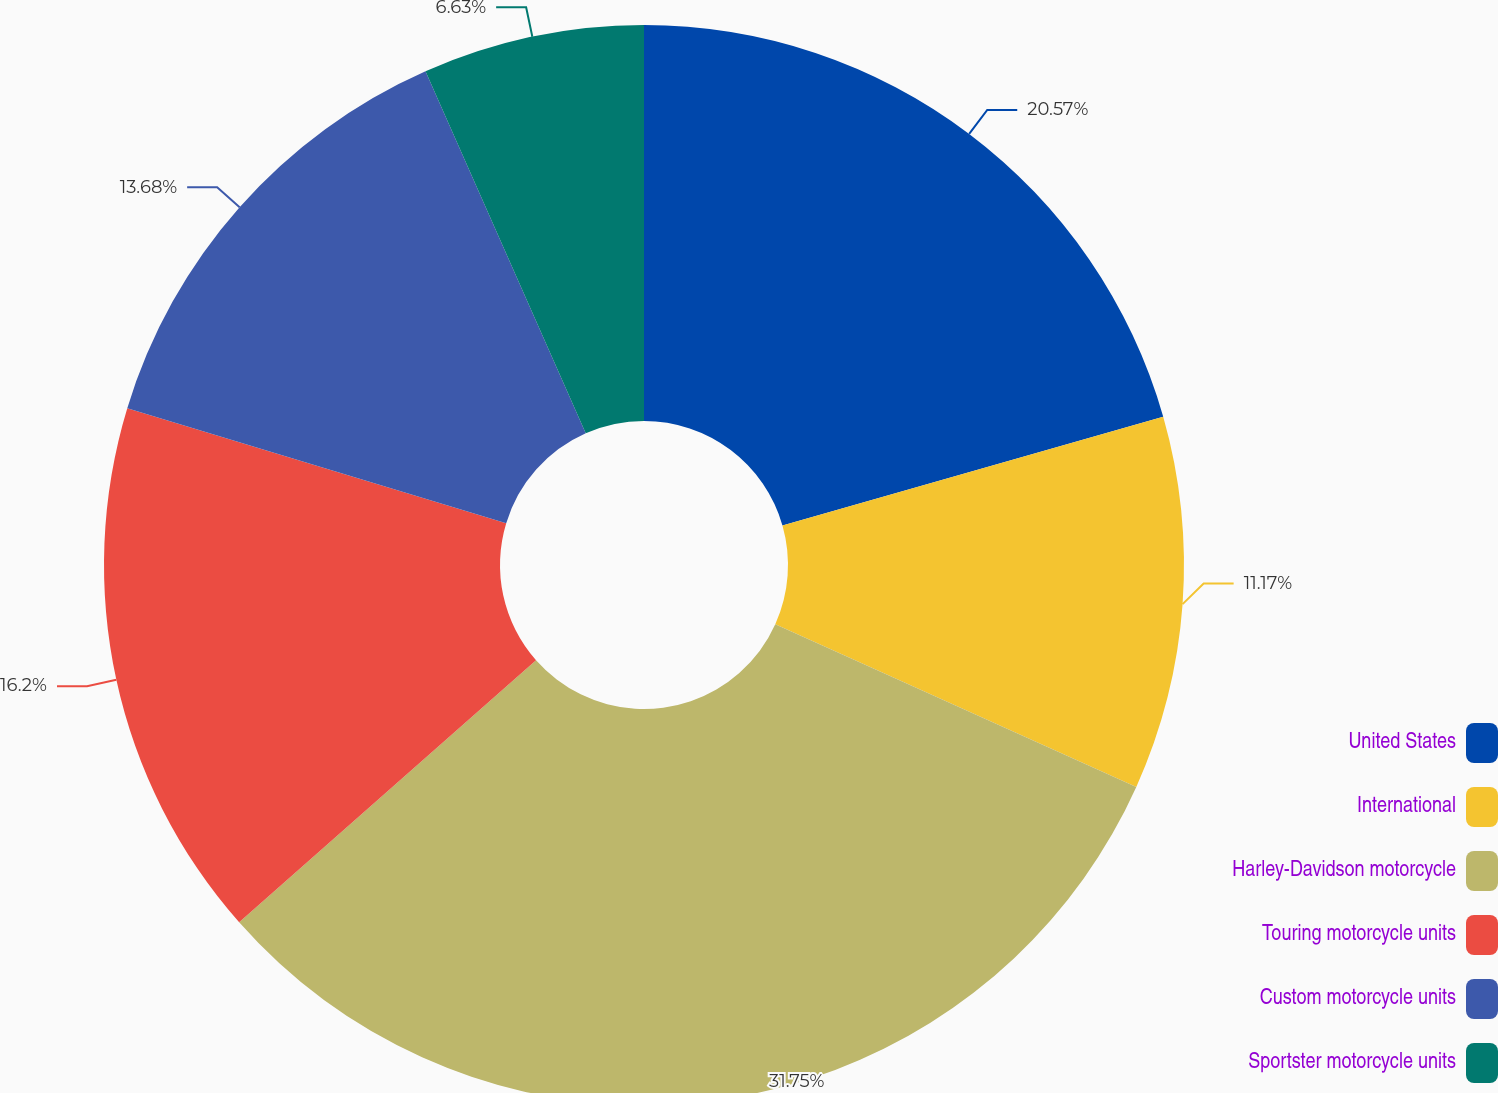<chart> <loc_0><loc_0><loc_500><loc_500><pie_chart><fcel>United States<fcel>International<fcel>Harley-Davidson motorcycle<fcel>Touring motorcycle units<fcel>Custom motorcycle units<fcel>Sportster motorcycle units<nl><fcel>20.57%<fcel>11.17%<fcel>31.75%<fcel>16.2%<fcel>13.68%<fcel>6.63%<nl></chart> 